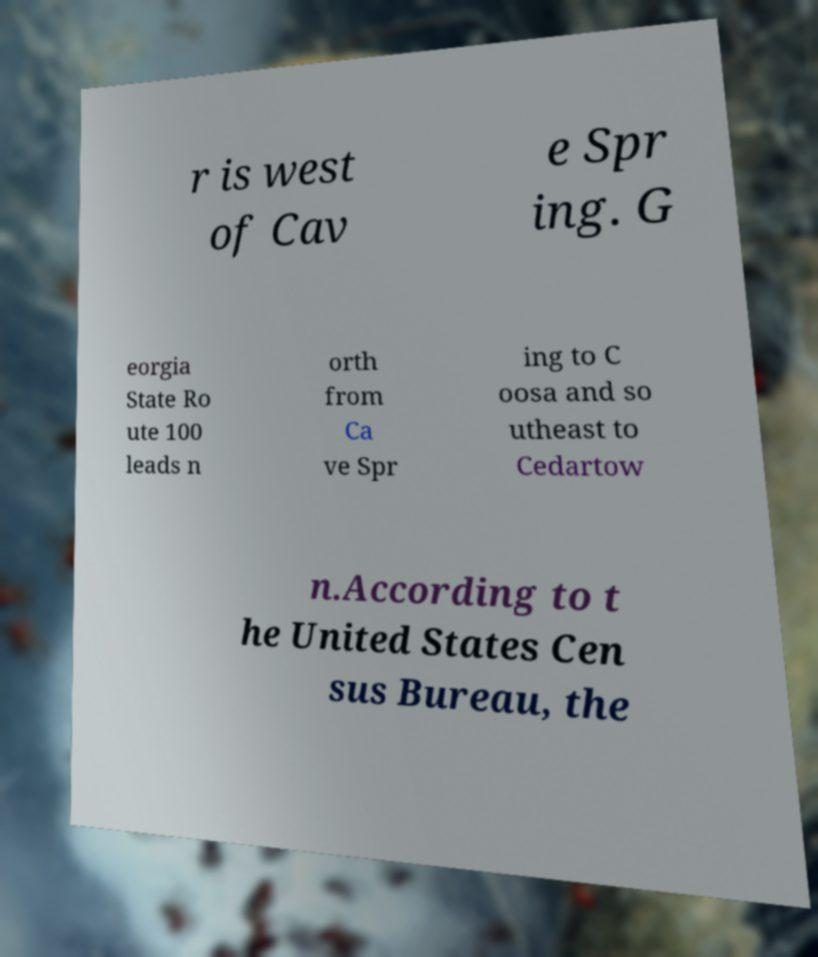I need the written content from this picture converted into text. Can you do that? r is west of Cav e Spr ing. G eorgia State Ro ute 100 leads n orth from Ca ve Spr ing to C oosa and so utheast to Cedartow n.According to t he United States Cen sus Bureau, the 